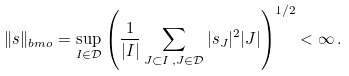<formula> <loc_0><loc_0><loc_500><loc_500>\| { s } \| _ { b m o } = \sup _ { I \in \mathcal { D } } \left ( \frac { 1 } { | I | } \sum _ { J \subset I \, , J \in \mathcal { D } } | s _ { J } | ^ { 2 } | J | \right ) ^ { 1 / 2 } < \infty \, .</formula> 